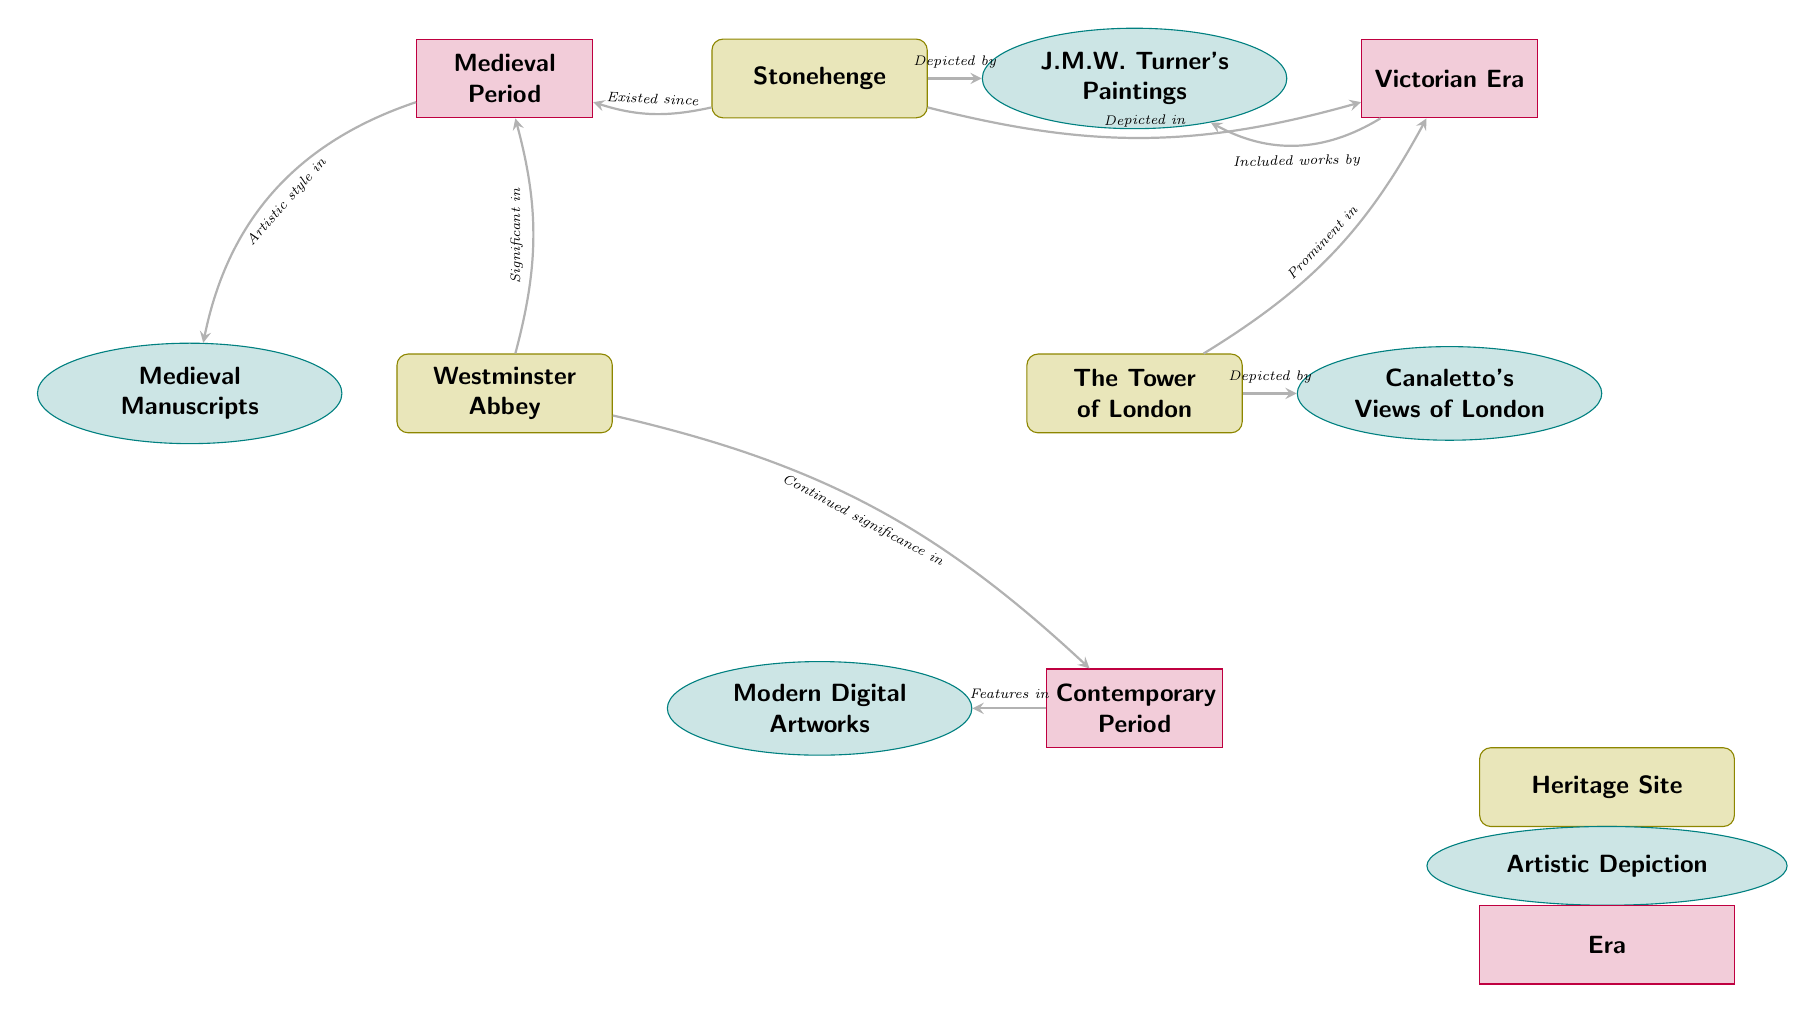What heritage site is connected to the Medieval Period? The diagram shows a connection from Stonehenge to the Medieval Period node, indicating it is associated with that era.
Answer: Stonehenge How many artistic depictions are shown in the diagram? The diagram includes four artistic depictions: J.M.W. Turner's Paintings, Canaletto's Views of London, Medieval Manuscripts, and Modern Digital Artworks. Counting these gives us four depictions.
Answer: 4 Which artistic depiction is linked to the Victorian Era? The connection from the Victorian Era node leads to both J.M.W. Turner's Paintings and The Tower of London node, indicating they are significant during this period. Thus, J.M.W. Turner's Paintings is a direct answer.
Answer: J.M.W. Turner's Paintings What connection does Westminster Abbey have in the Contemporary Period? The diagram shows a connection from Westminster Abbey to the Contemporary Period node, indicating that it continues to hold significance in modern times.
Answer: Continued significance Which heritage site is depicted by Canaletto? The diagram shows a direct connection from The Tower of London to Canaletto's Views of London, indicating that this heritage site is illustrated by Canaletto's artwork.
Answer: The Tower of London How many nodes are depicted in total? The diagram features a total of seven nodes: three heritage sites, four artistic depictions, and three eras. Thus, to find the total, we add these together: 3 heritage sites + 4 artistic depictions + 3 eras = 10 nodes.
Answer: 10 What is the relationship between the Medieval Period and Medieval Manuscripts? The diagram indicates a connection from the Medieval Period to the Medieval Manuscripts, showing that this type of artistic work represents the style prevalent during that era.
Answer: Artistic style in Which era is associated with Modern Digital Artworks? The diagram connects Modern Digital Artworks to the Contemporary Period node, indicating this artistic depiction belongs to this specific era.
Answer: Contemporary Period What depicts Stonehenge in the Victorian Era? There is a directed connection to the Victorian Era indicating that Stonehenge was depicted by artistic works during this time; the node that represents this is J.M.W. Turner's Paintings, which is highlighted in the diagram.
Answer: J.M.W. Turner's Paintings 